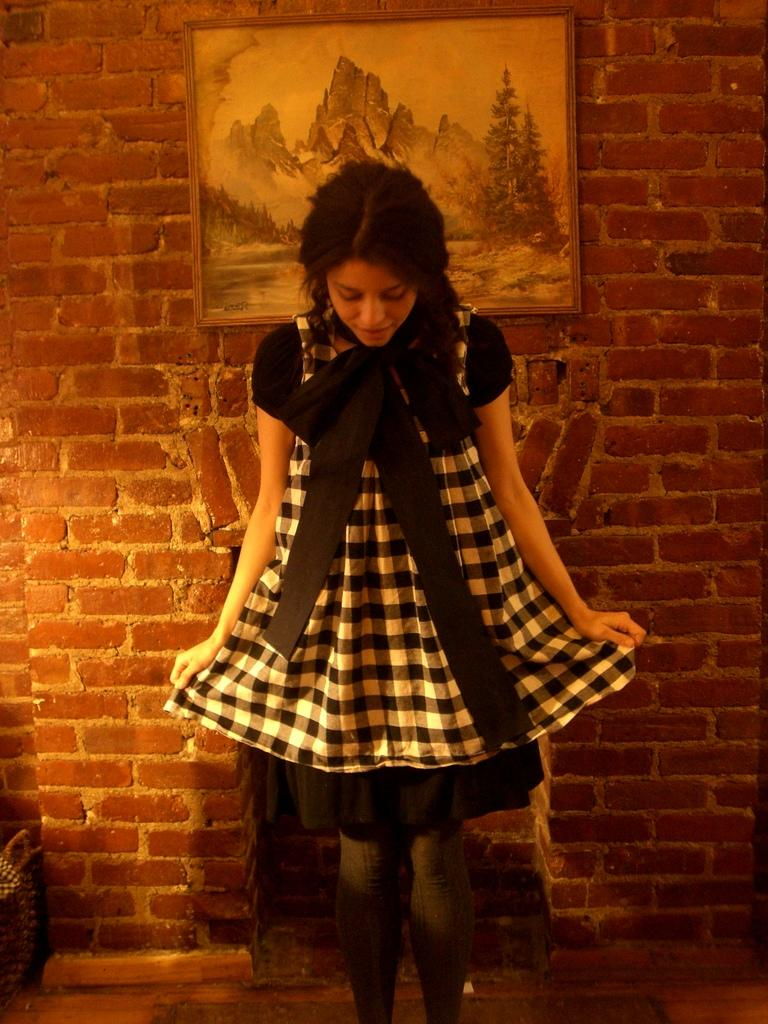What is the main subject in the image? There is a woman standing in the image. What can be seen on the wall in the image? There is a frame on a wall in the image. What object is on the floor in the image? There is a bag on the floor in the image. What type of yoke is being used by the woman in the image? There is no yoke present in the image, and the woman is not using any yoke. What type of grape can be seen growing on the wall in the image? There are no grapes present in the image, and there is no indication of any plants or vegetation on the wall. 